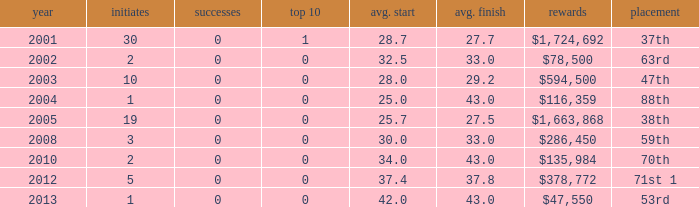How many starts for an average finish greater than 43? None. 